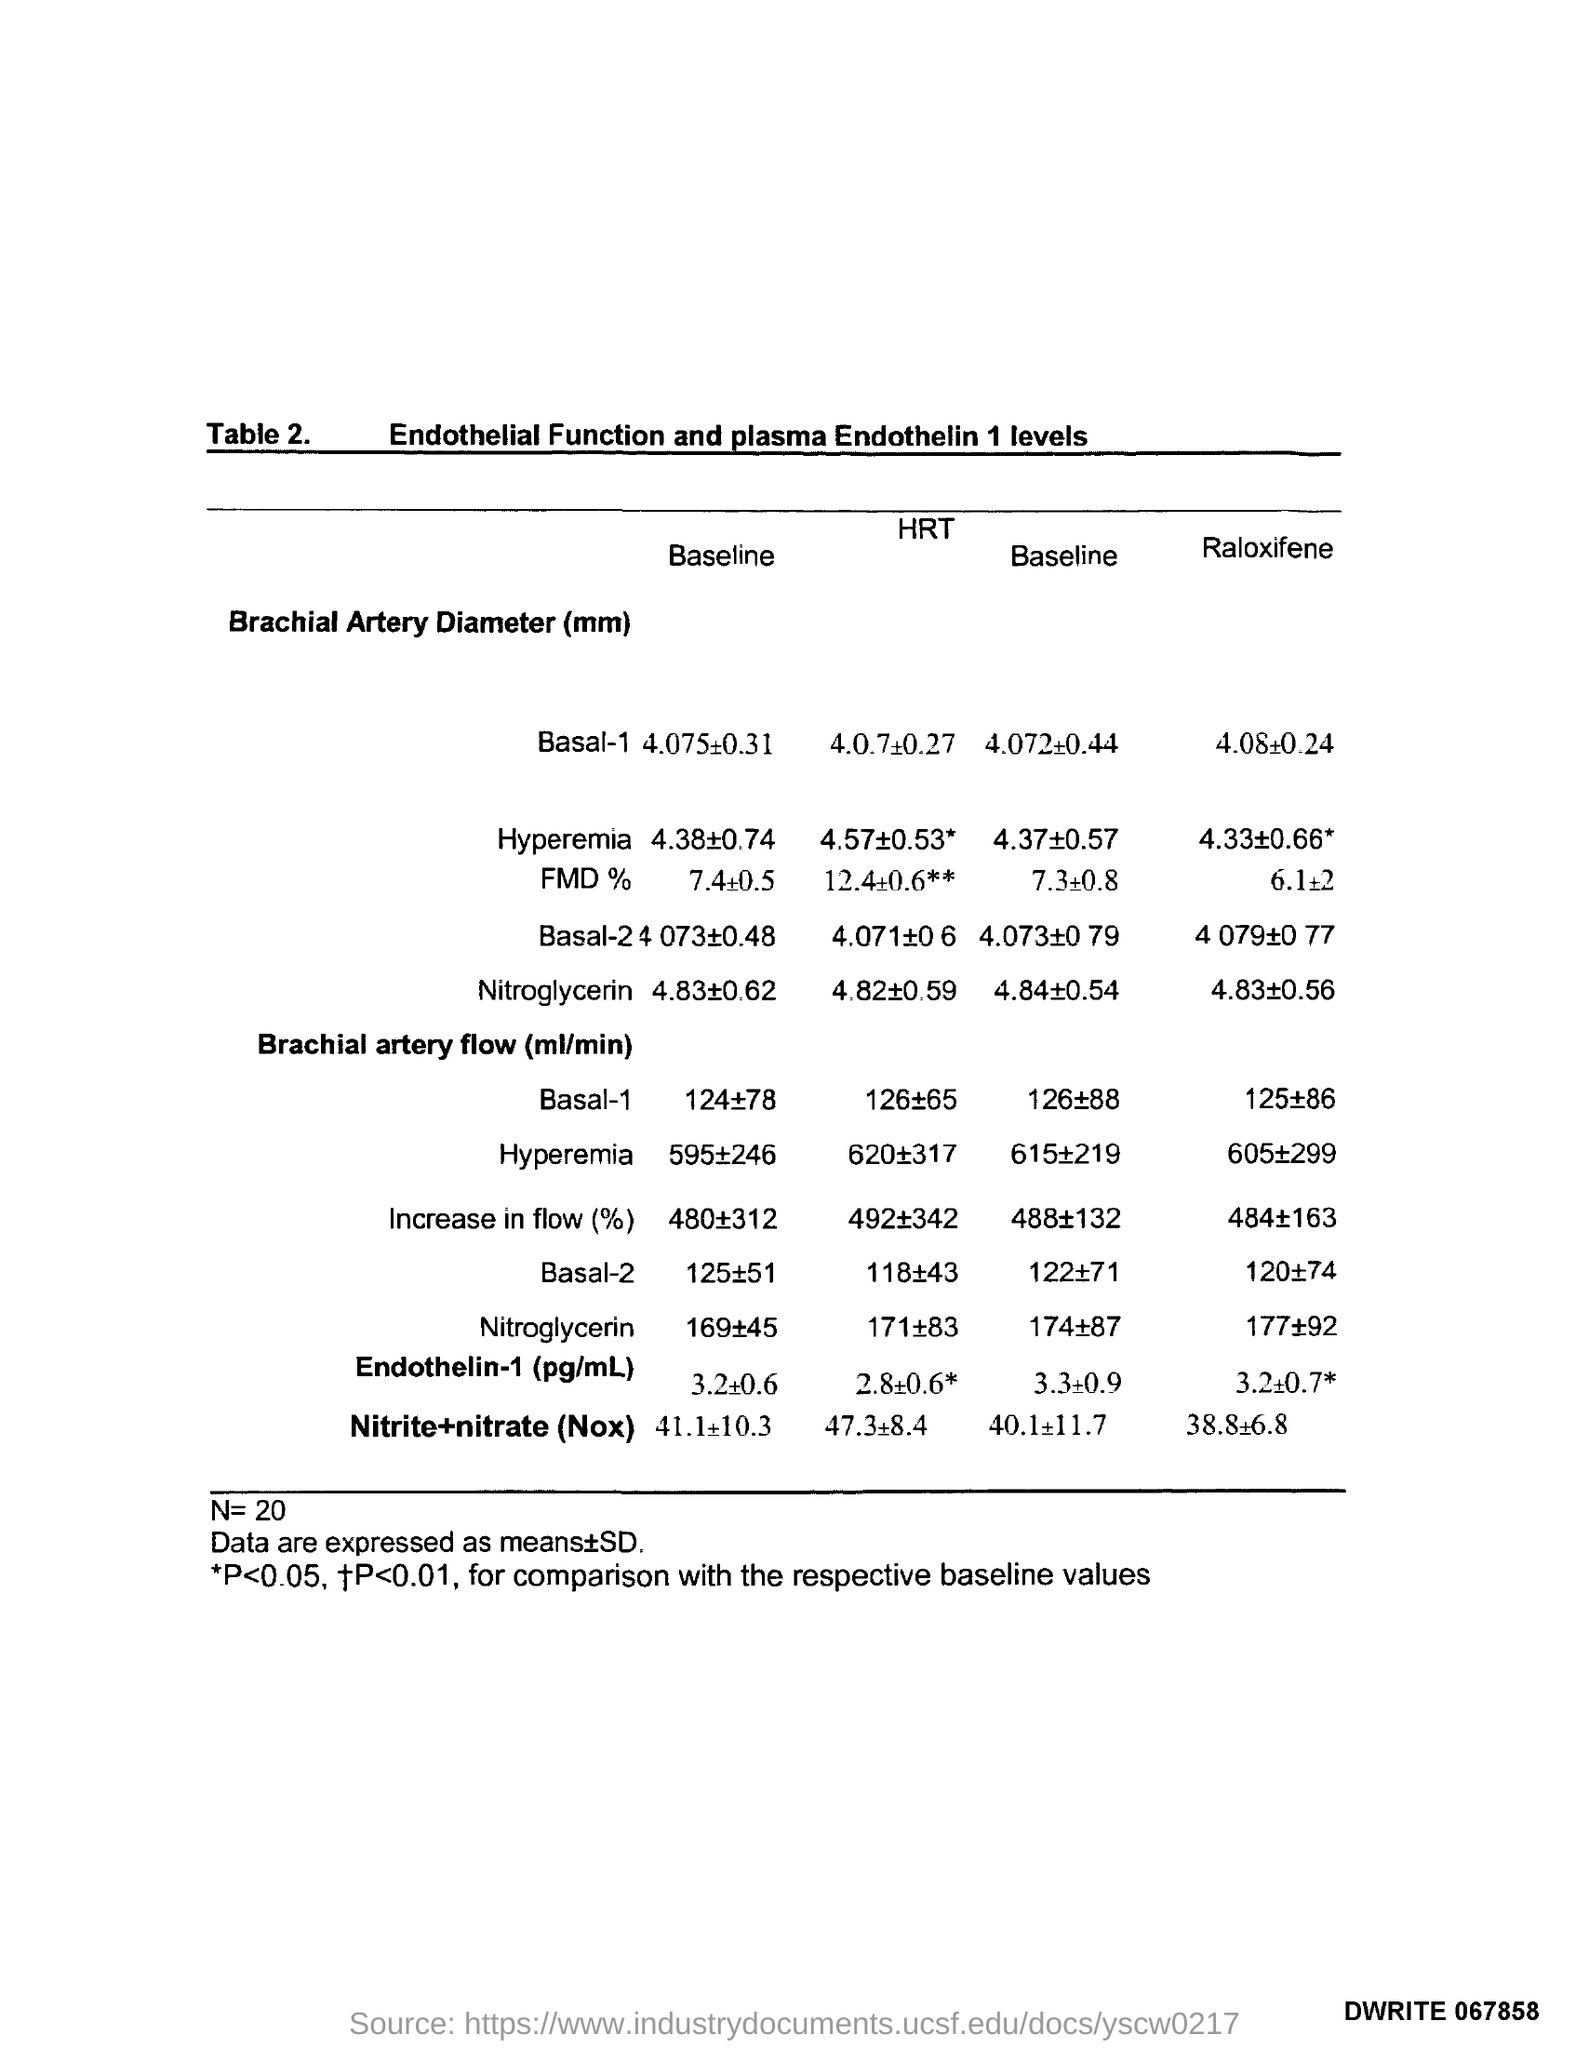Highlight a few significant elements in this photo. The value of N is 20. The title of the table is "Table 2. Endothelial Function and Plasma Endothelin 1 Levels.". 